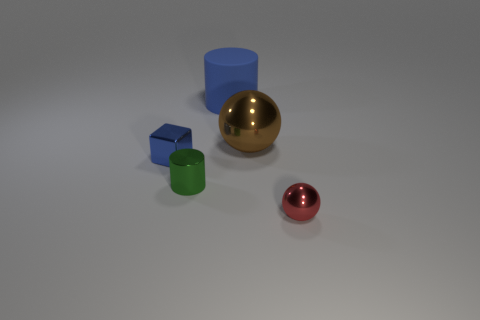Add 1 tiny gray rubber cylinders. How many objects exist? 6 Subtract all cylinders. How many objects are left? 3 Add 4 blue matte things. How many blue matte things are left? 5 Add 2 big cylinders. How many big cylinders exist? 3 Subtract 1 blue cylinders. How many objects are left? 4 Subtract all small blue blocks. Subtract all small cylinders. How many objects are left? 3 